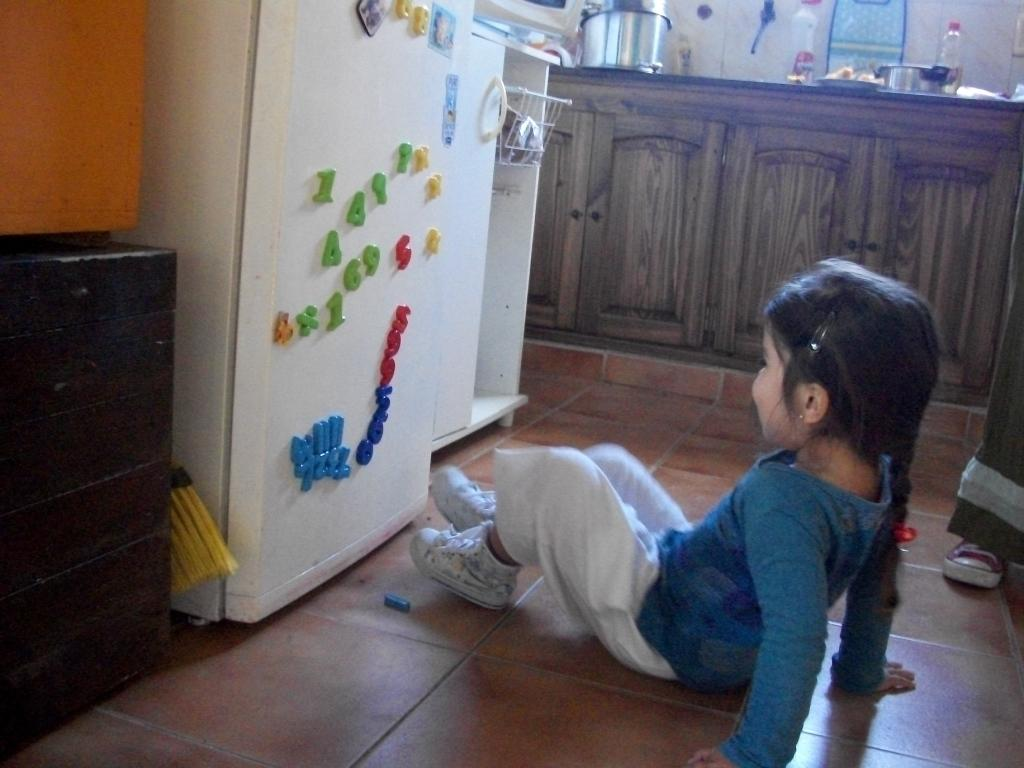<image>
Give a short and clear explanation of the subsequent image. A little girl sits in front of a fridge with 4, 4, 1, X and X magnets on it. 